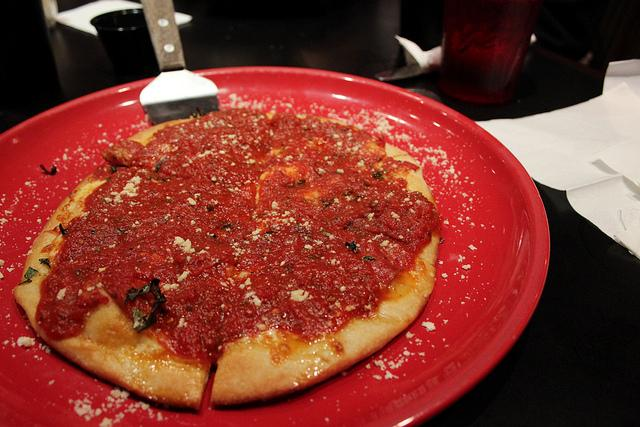What is there an excessive amount of relative to most pizzas? sauce 